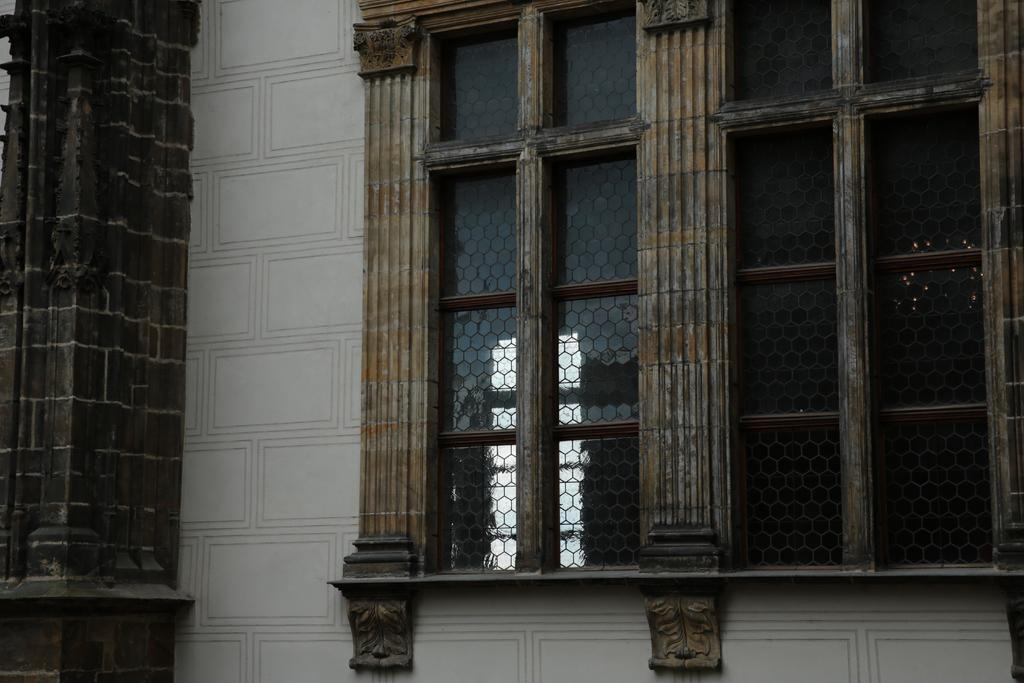What is the main structure in the image? There is a building in the image. What are some features of the building? The building has windows and a pillar. What religious scene is depicted in the image? There is no religious scene depicted in the image; it only features a building with windows and a pillar. What advice might the grandfather give in the image? There is no grandfather present in the image, so it is not possible to determine any advice he might give. 